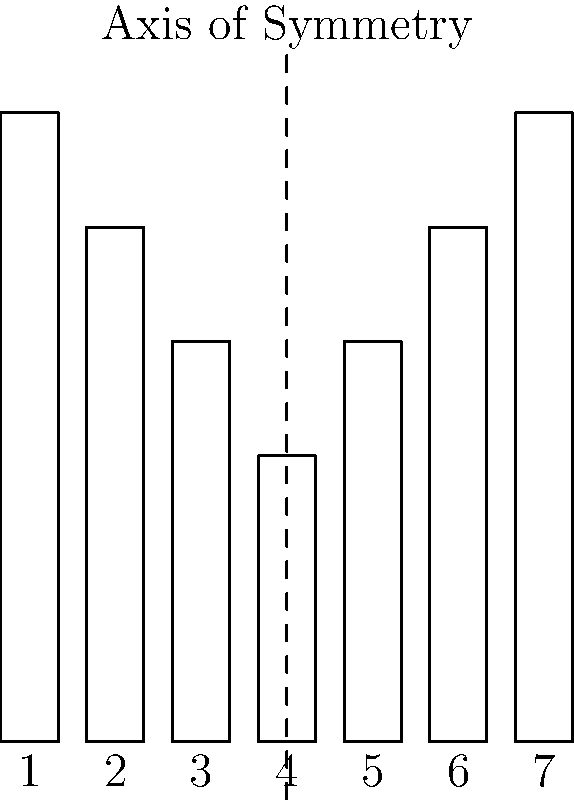In the diagram above, which represents the layout of organ pipes in a traditional organ, what type of symmetry is exhibited, and which pipe forms the axis of symmetry? To determine the type of symmetry and the axis of symmetry in this organ pipe layout, we need to follow these steps:

1. Observe the arrangement of the pipes:
   The pipes are arranged in a pattern where the heights increase towards the center and then decrease.

2. Identify the symmetry:
   The layout exhibits reflectional symmetry, also known as mirror symmetry or bilateral symmetry.

3. Locate the axis of symmetry:
   The dashed line in the center of the diagram represents the axis of symmetry.

4. Determine which pipe forms the axis of symmetry:
   The pipe labeled "4" is centered on the axis of symmetry.

5. Verify the symmetry:
   - Pipe 1 and Pipe 7 have the same height
   - Pipe 2 and Pipe 6 have the same height
   - Pipe 3 and Pipe 5 have the same height
   - Pipe 4 is in the center and is the tallest

This arrangement is typical in traditional organ design, where the central pipes are often the largest and most prominent, creating a visually balanced and symmetrical appearance that aligns with classical aesthetic principles in organ construction.
Answer: Reflectional symmetry; Pipe 4 